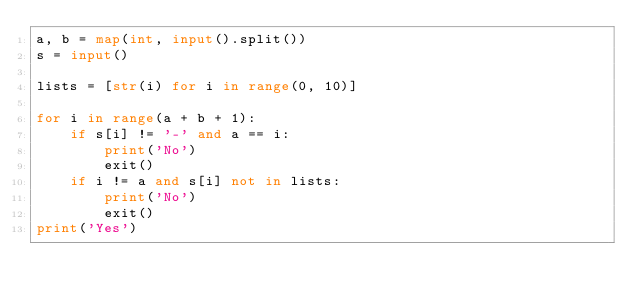<code> <loc_0><loc_0><loc_500><loc_500><_Python_>a, b = map(int, input().split())
s = input()

lists = [str(i) for i in range(0, 10)]

for i in range(a + b + 1):
    if s[i] != '-' and a == i:
        print('No')
        exit()
    if i != a and s[i] not in lists:
        print('No')
        exit()
print('Yes')
</code> 